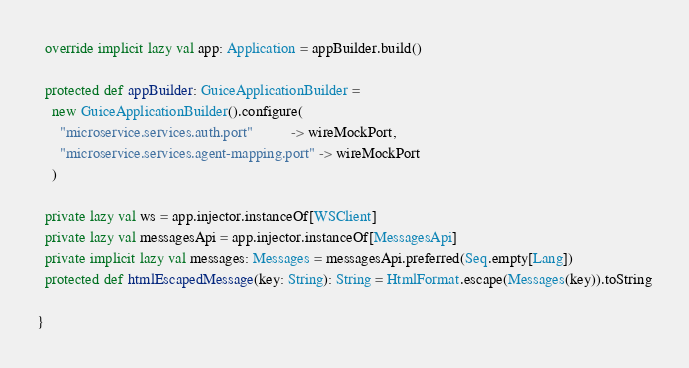<code> <loc_0><loc_0><loc_500><loc_500><_Scala_>
  override implicit lazy val app: Application = appBuilder.build()

  protected def appBuilder: GuiceApplicationBuilder =
    new GuiceApplicationBuilder().configure(
      "microservice.services.auth.port"          -> wireMockPort,
      "microservice.services.agent-mapping.port" -> wireMockPort
    )

  private lazy val ws = app.injector.instanceOf[WSClient]
  private lazy val messagesApi = app.injector.instanceOf[MessagesApi]
  private implicit lazy val messages: Messages = messagesApi.preferred(Seq.empty[Lang])
  protected def htmlEscapedMessage(key: String): String = HtmlFormat.escape(Messages(key)).toString

}
</code> 